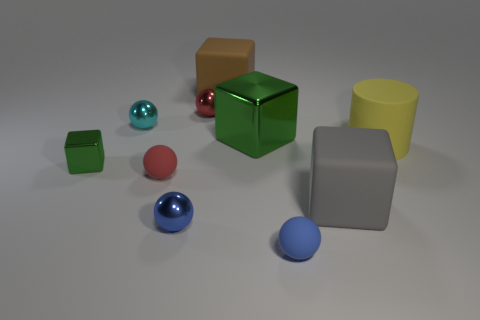Are there more metal objects that are behind the large yellow matte cylinder than yellow balls?
Provide a succinct answer. Yes. There is a blue matte sphere in front of the cyan metallic sphere; is it the same size as the red metal thing?
Offer a very short reply. Yes. There is a cube that is both right of the big brown thing and in front of the large yellow cylinder; what color is it?
Keep it short and to the point. Gray. There is a yellow rubber object that is the same size as the gray object; what shape is it?
Offer a very short reply. Cylinder. Are there any small blocks of the same color as the large shiny block?
Your answer should be very brief. Yes. Are there the same number of matte things to the left of the yellow thing and large green things?
Offer a terse response. No. Does the big metallic block have the same color as the tiny cube?
Provide a short and direct response. Yes. There is a ball that is in front of the tiny cyan ball and behind the blue metal object; what is its size?
Your answer should be compact. Small. There is another block that is made of the same material as the large gray cube; what is its color?
Provide a succinct answer. Brown. What number of other cylinders have the same material as the yellow cylinder?
Your answer should be compact. 0. 